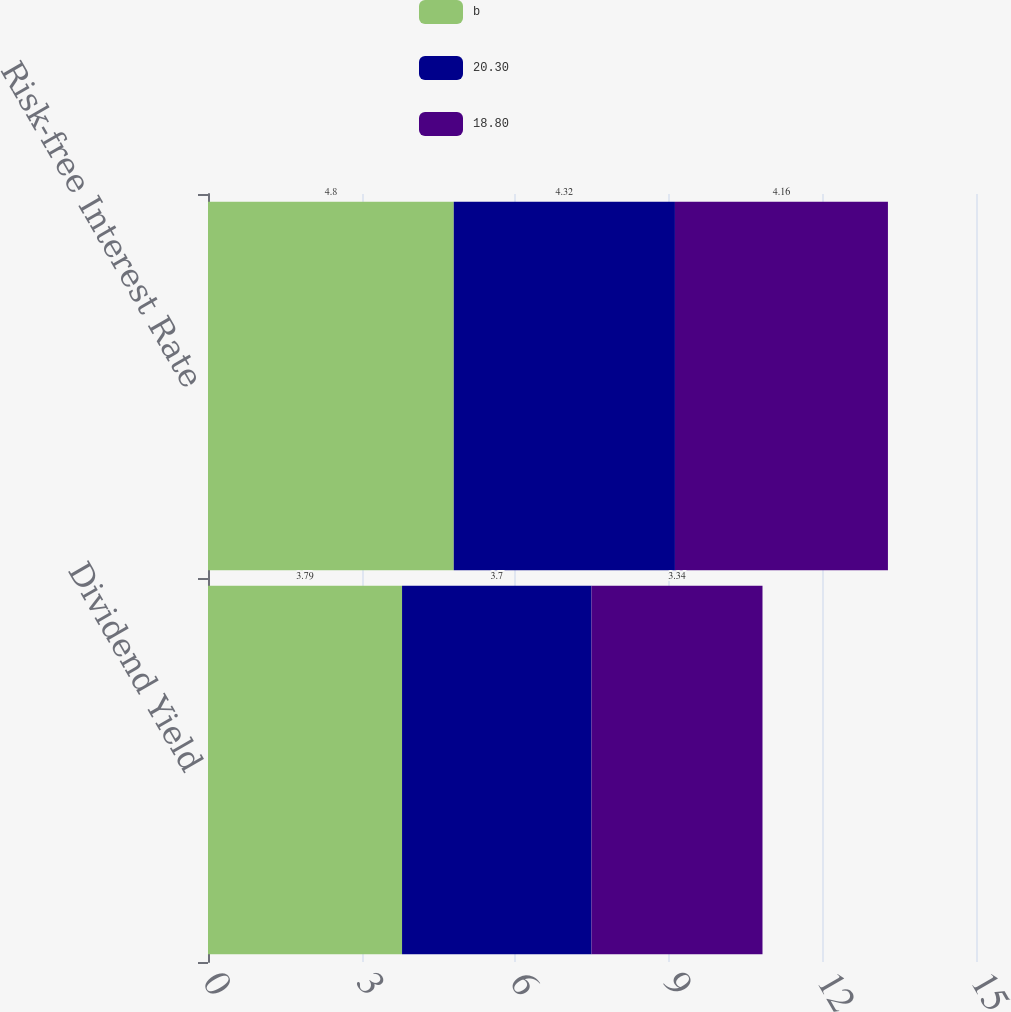<chart> <loc_0><loc_0><loc_500><loc_500><stacked_bar_chart><ecel><fcel>Dividend Yield<fcel>Risk-free Interest Rate<nl><fcel>b<fcel>3.79<fcel>4.8<nl><fcel>20.30<fcel>3.7<fcel>4.32<nl><fcel>18.80<fcel>3.34<fcel>4.16<nl></chart> 